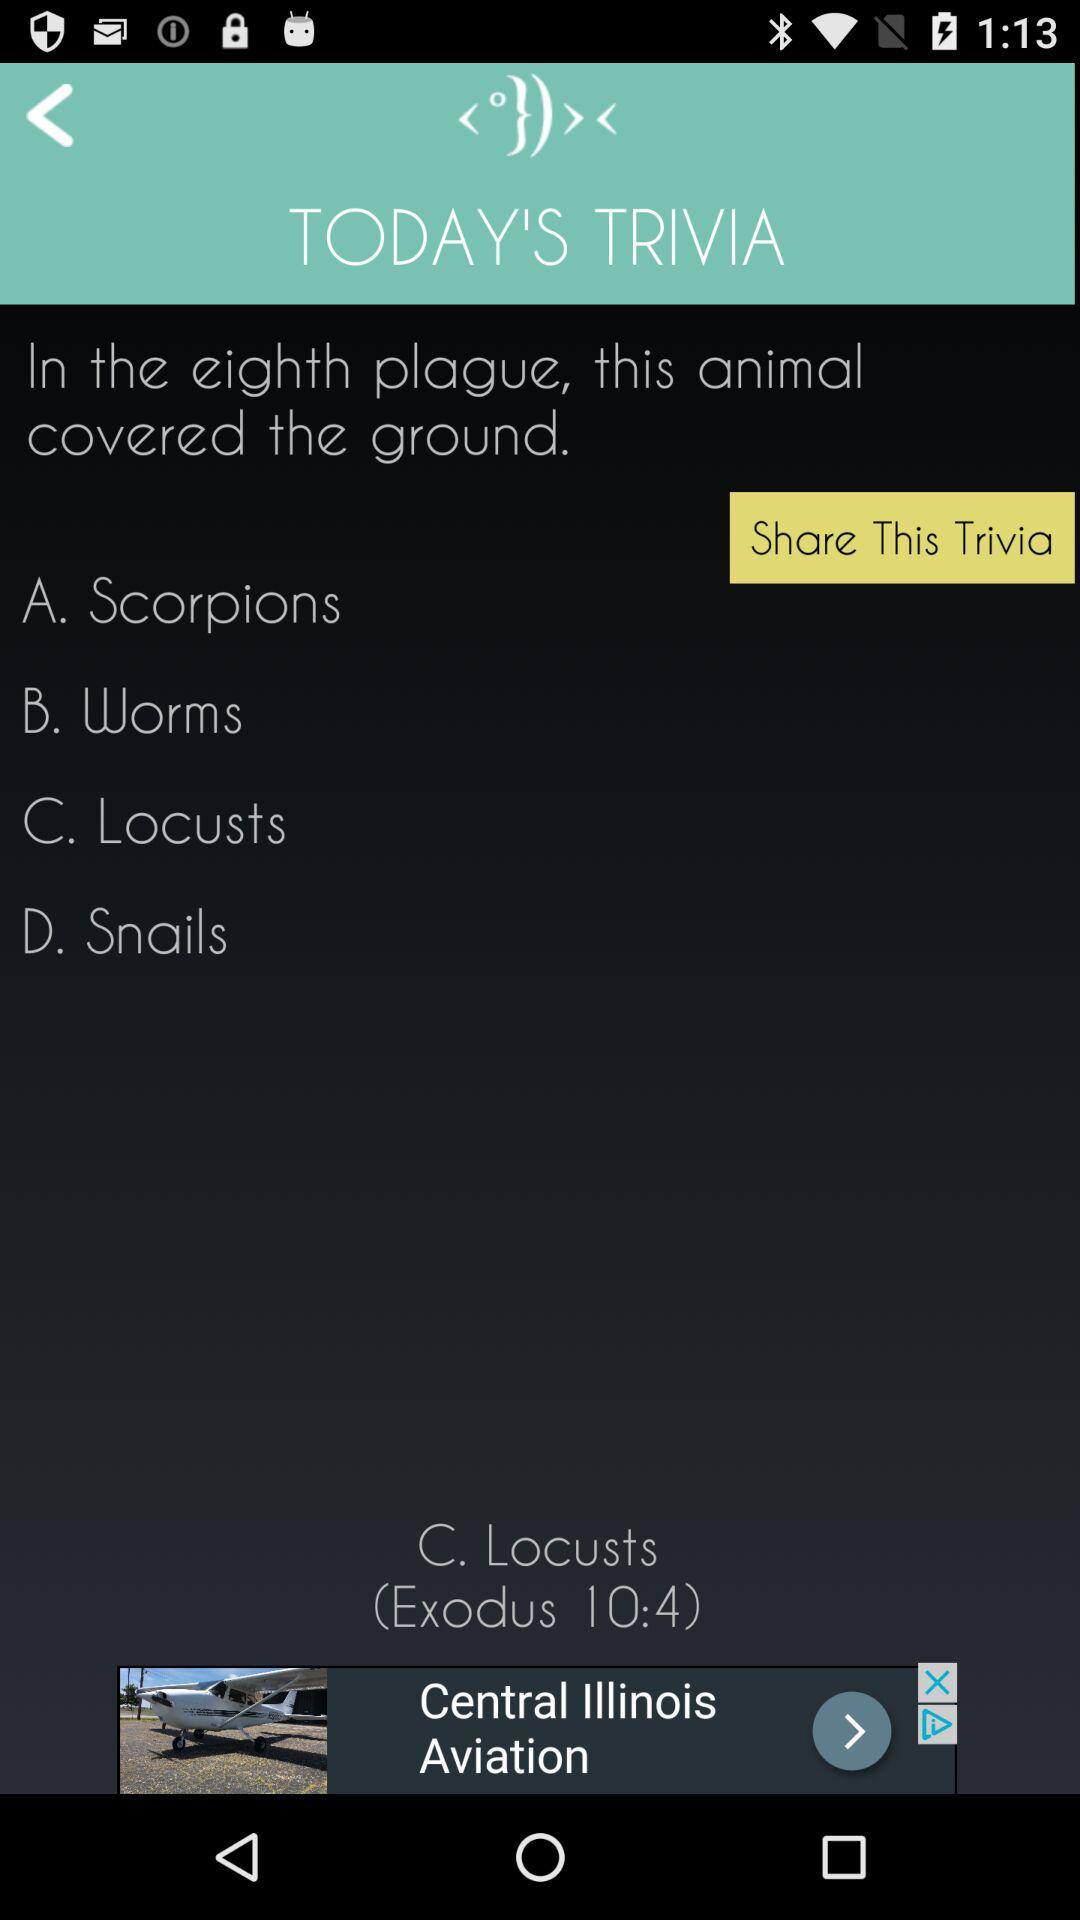How many answers are there to the trivia question?
Answer the question using a single word or phrase. 4 